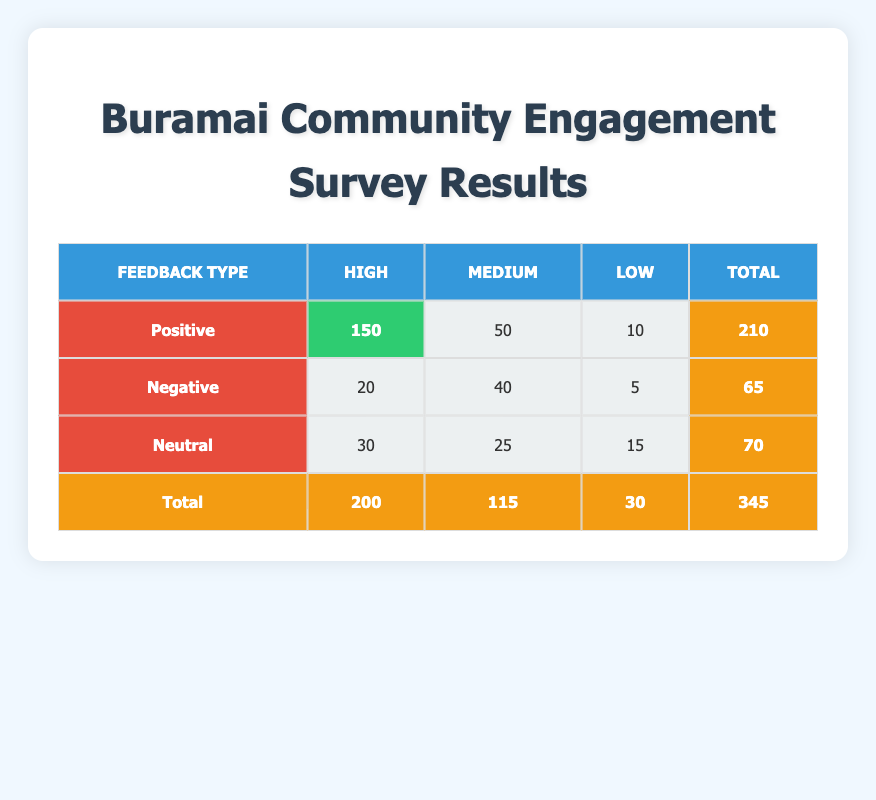What is the total count of positive feedback with high response quality? The table shows that for the "Positive" feedback type, the "High" response quality has a count of 150. Therefore, the total count is directly taken from this entry.
Answer: 150 What is the highest number of responses for a single feedback type regarding response quality? By examining the table, we note that the highest count appears under "Positive" feedback type with "High" quality as 150 responses. No other count reaches this value.
Answer: 150 How many total negative feedback responses are there? To find this, we add the counts for "Negative" feedback across all response qualities: 20 (High) + 40 (Medium) + 5 (Low) = 65 total negative responses.
Answer: 65 Is it true that more than half of the total responses are positive? The total number of responses is 345 (sum of all counts). Positive responses are 210, which is indeed more than half of 345, thus making the statement true.
Answer: Yes What is the average count of high response quality across all feedback types? First, we have counts for high responses only: 150 (Positive) + 20 (Negative) + 30 (Neutral) = 200. Dividing this by the number of feedback types (3) gives 200/3 = approximately 66.67.
Answer: Approximately 66.67 What is the difference between counts of positive and negative medium feedback? For "Positive" medium feedback, the count is 50, while for "Negative" medium feedback, it's 40. Therefore, the difference is 50 - 40 = 10.
Answer: 10 What percentage of total responses are classified as neutral feedback? Neutral feedback responses total 70. To find the percentage, we calculate (70/345) * 100 ≈ 20.29%.
Answer: Approximately 20.29% Which feedback type has the lowest response count for low quality? By checking the table, "Negative" feedback has the lowest count for low quality at 5, compared to 10 (Positive) and 15 (Neutral).
Answer: Negative How many more high quality responses are there in positive feedback than in neutral feedback? High quality responses for Positive are 150, while for Neutral they are 30. The difference is 150 - 30 = 120 more responses in Positive feedback.
Answer: 120 